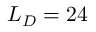<formula> <loc_0><loc_0><loc_500><loc_500>L _ { D } = 2 4</formula> 